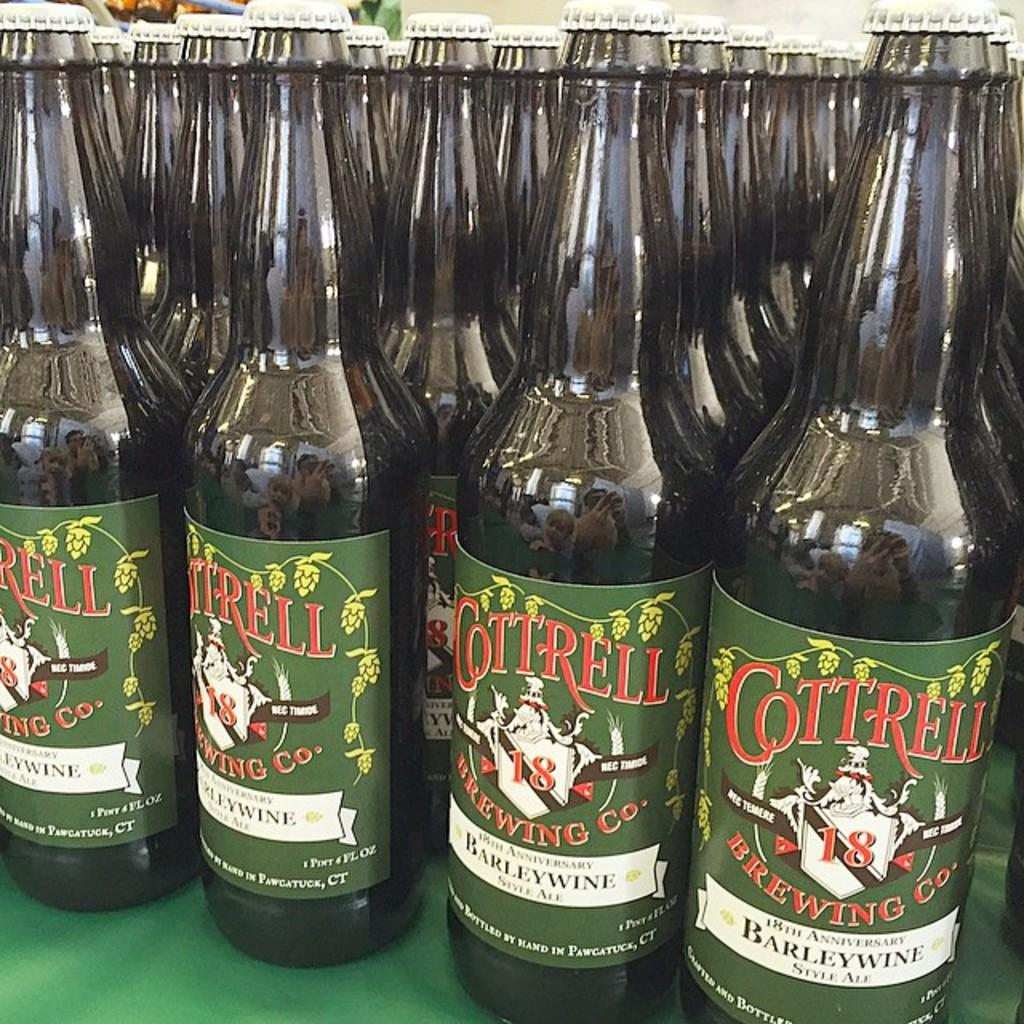<image>
Describe the image concisely. Bottles of barley wine made by the Cottrell Brewing Co. on a table. 